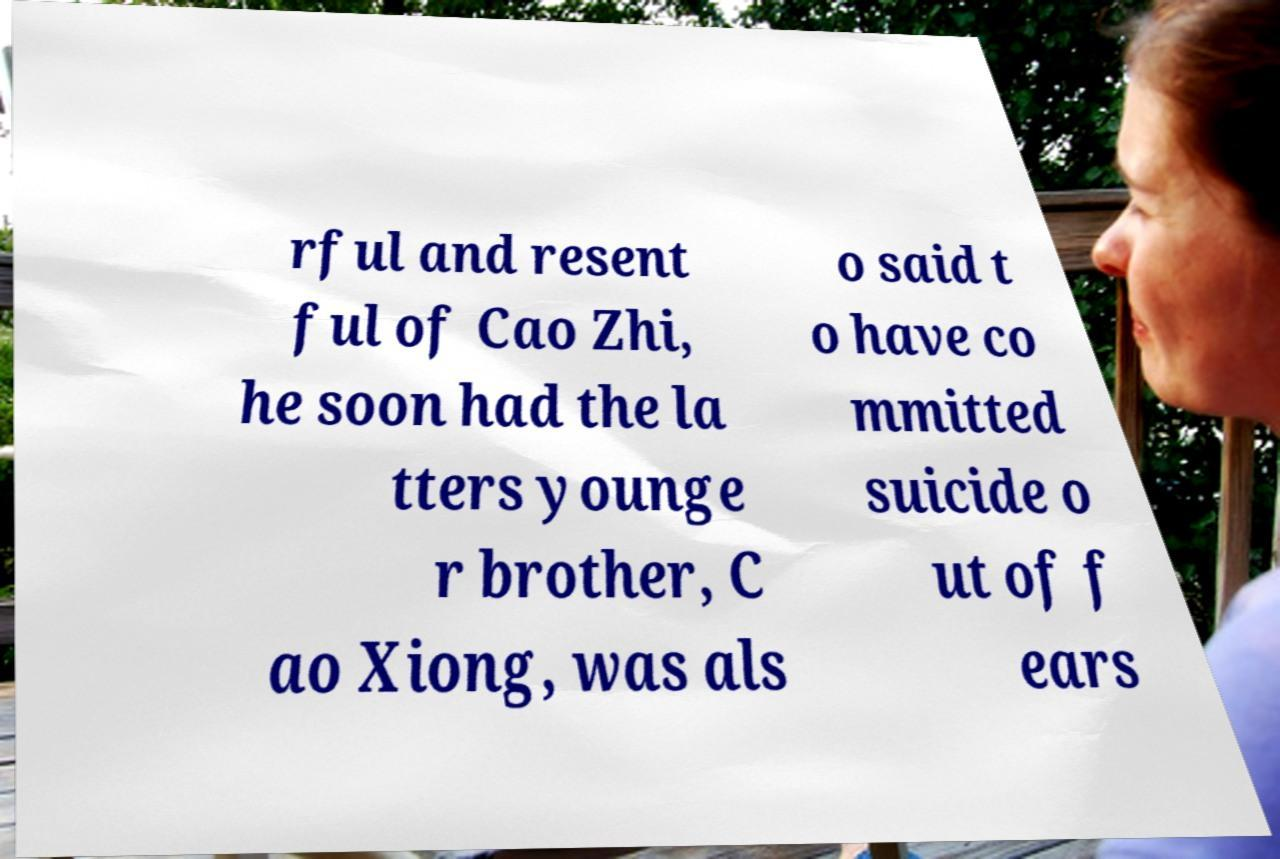For documentation purposes, I need the text within this image transcribed. Could you provide that? rful and resent ful of Cao Zhi, he soon had the la tters younge r brother, C ao Xiong, was als o said t o have co mmitted suicide o ut of f ears 